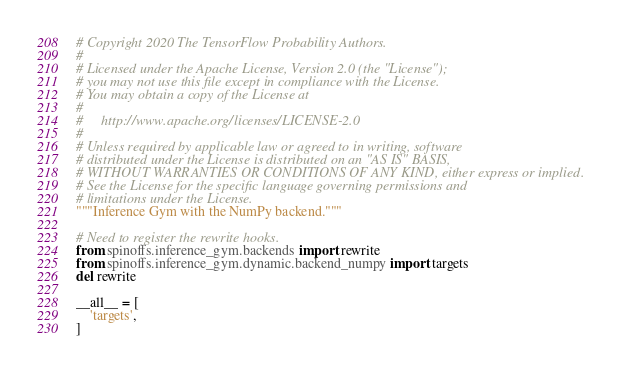Convert code to text. <code><loc_0><loc_0><loc_500><loc_500><_Python_># Copyright 2020 The TensorFlow Probability Authors.
#
# Licensed under the Apache License, Version 2.0 (the "License");
# you may not use this file except in compliance with the License.
# You may obtain a copy of the License at
#
#     http://www.apache.org/licenses/LICENSE-2.0
#
# Unless required by applicable law or agreed to in writing, software
# distributed under the License is distributed on an "AS IS" BASIS,
# WITHOUT WARRANTIES OR CONDITIONS OF ANY KIND, either express or implied.
# See the License for the specific language governing permissions and
# limitations under the License.
"""Inference Gym with the NumPy backend."""

# Need to register the rewrite hooks.
from spinoffs.inference_gym.backends import rewrite
from spinoffs.inference_gym.dynamic.backend_numpy import targets
del rewrite

__all__ = [
    'targets',
]
</code> 